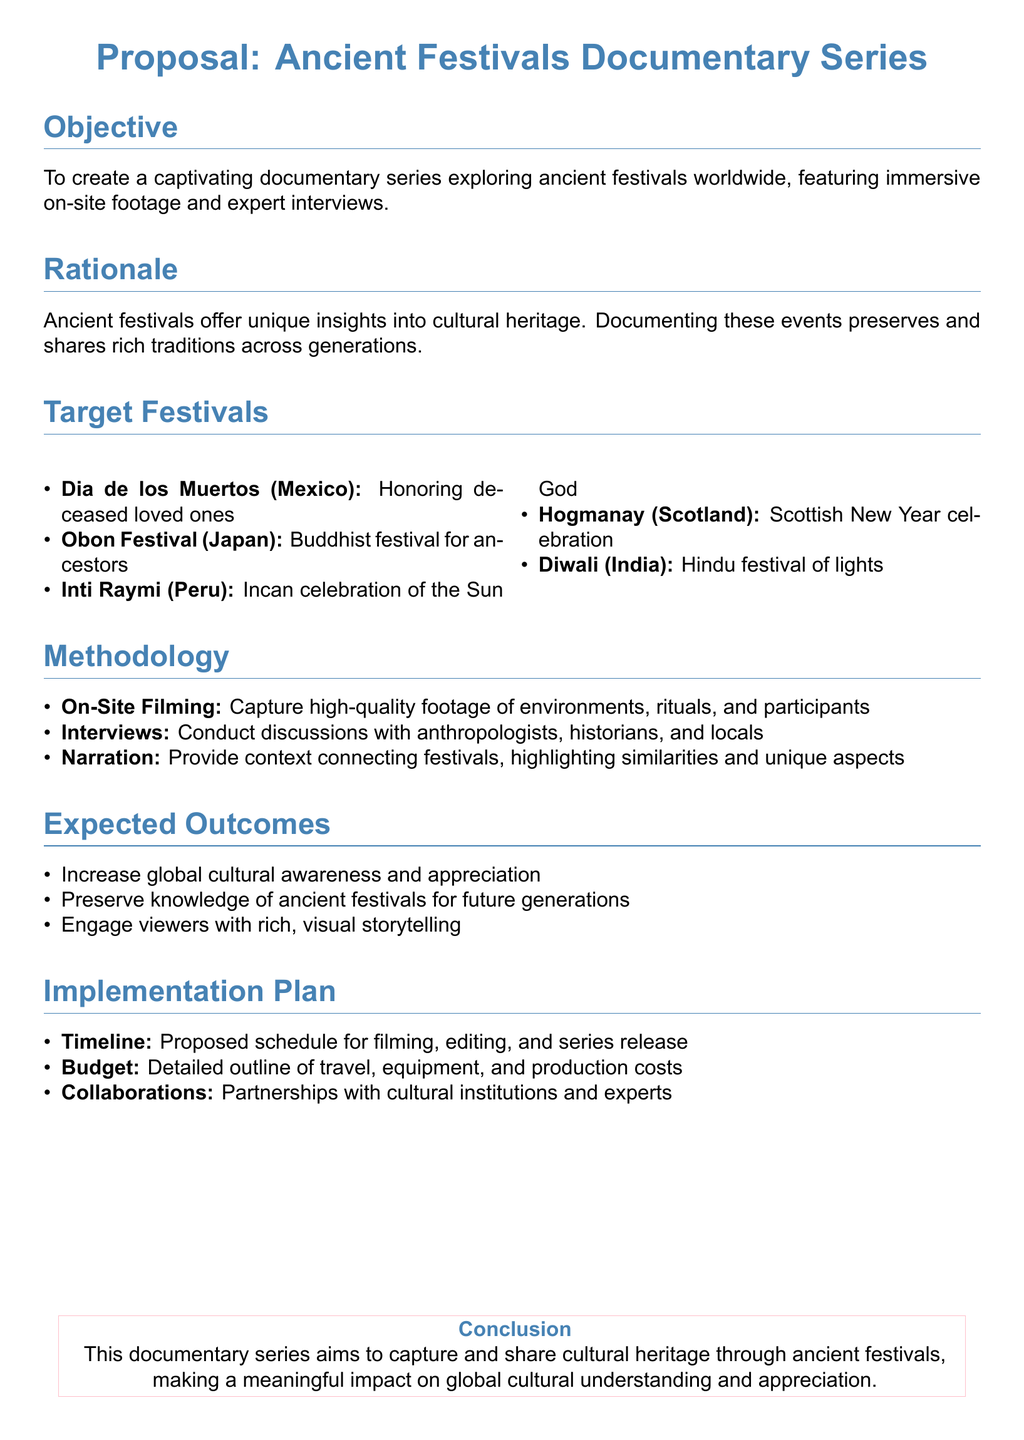What is the title of the documentary series? The title is mentioned in the proposal's heading.
Answer: Ancient Festivals Documentary Series What is the objective of the series? The objective details what the documentary aims to achieve.
Answer: To create a captivating documentary series exploring ancient festivals worldwide How many target festivals are listed? The proposal contains a section listing target festivals.
Answer: Five Which festival is known for honoring deceased loved ones? The festivals are described in the target festivals section.
Answer: Dia de los Muertos What is the expected outcome related to global awareness? The expected outcomes highlight the series' impact on culture.
Answer: Increase global cultural awareness and appreciation What methodology involves filming on location? The methodology outlines different approaches for the documentary.
Answer: On-Site Filming Which festival is associated with the Hindu festival of lights? This is another aspect covered in the target festivals list.
Answer: Diwali What is included in the implementation plan? The implementation plan details aspects related to project management.
Answer: Timeline Who will be interviewed for the documentary? The methodology mentions the types of people to interview.
Answer: Anthropologists, historians, and locals 